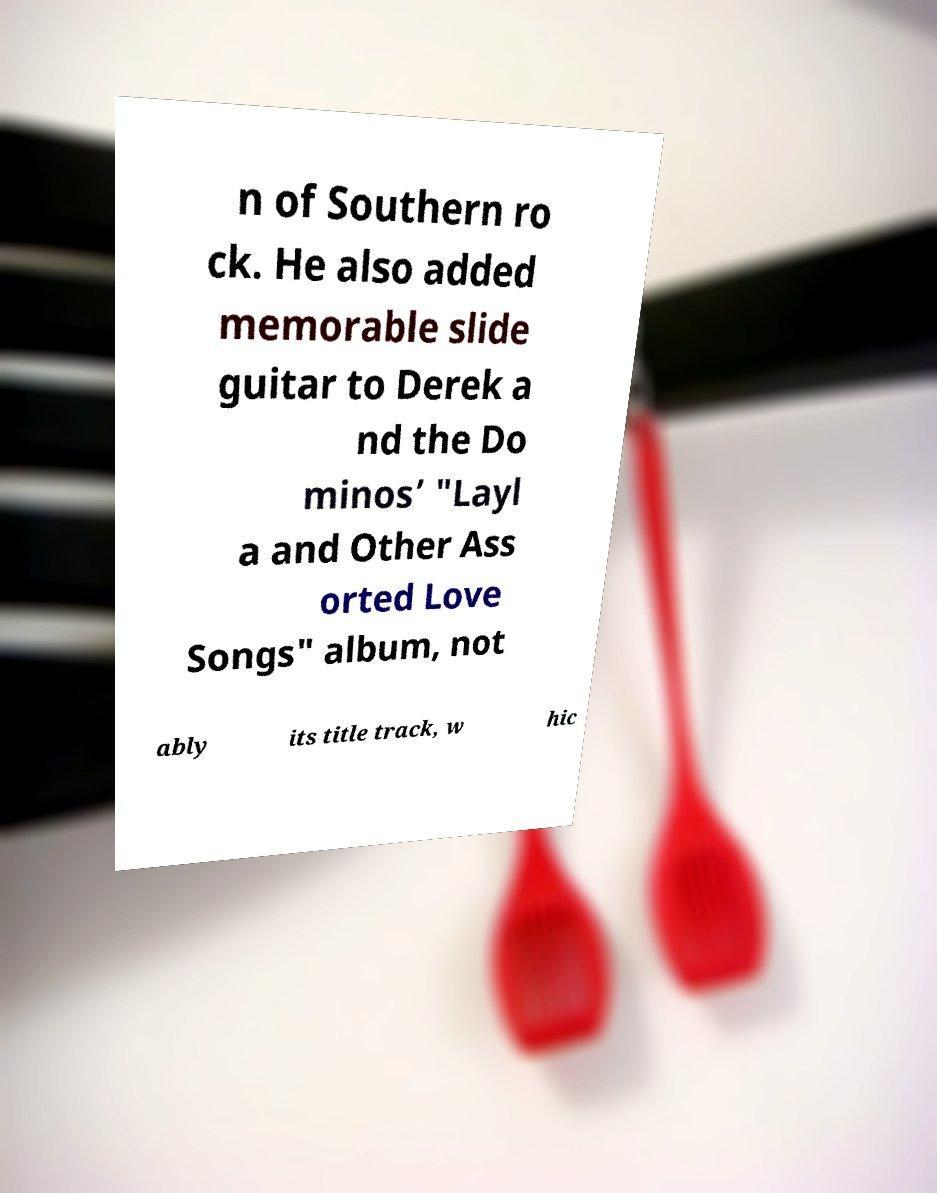Can you accurately transcribe the text from the provided image for me? n of Southern ro ck. He also added memorable slide guitar to Derek a nd the Do minos’ "Layl a and Other Ass orted Love Songs" album, not ably its title track, w hic 